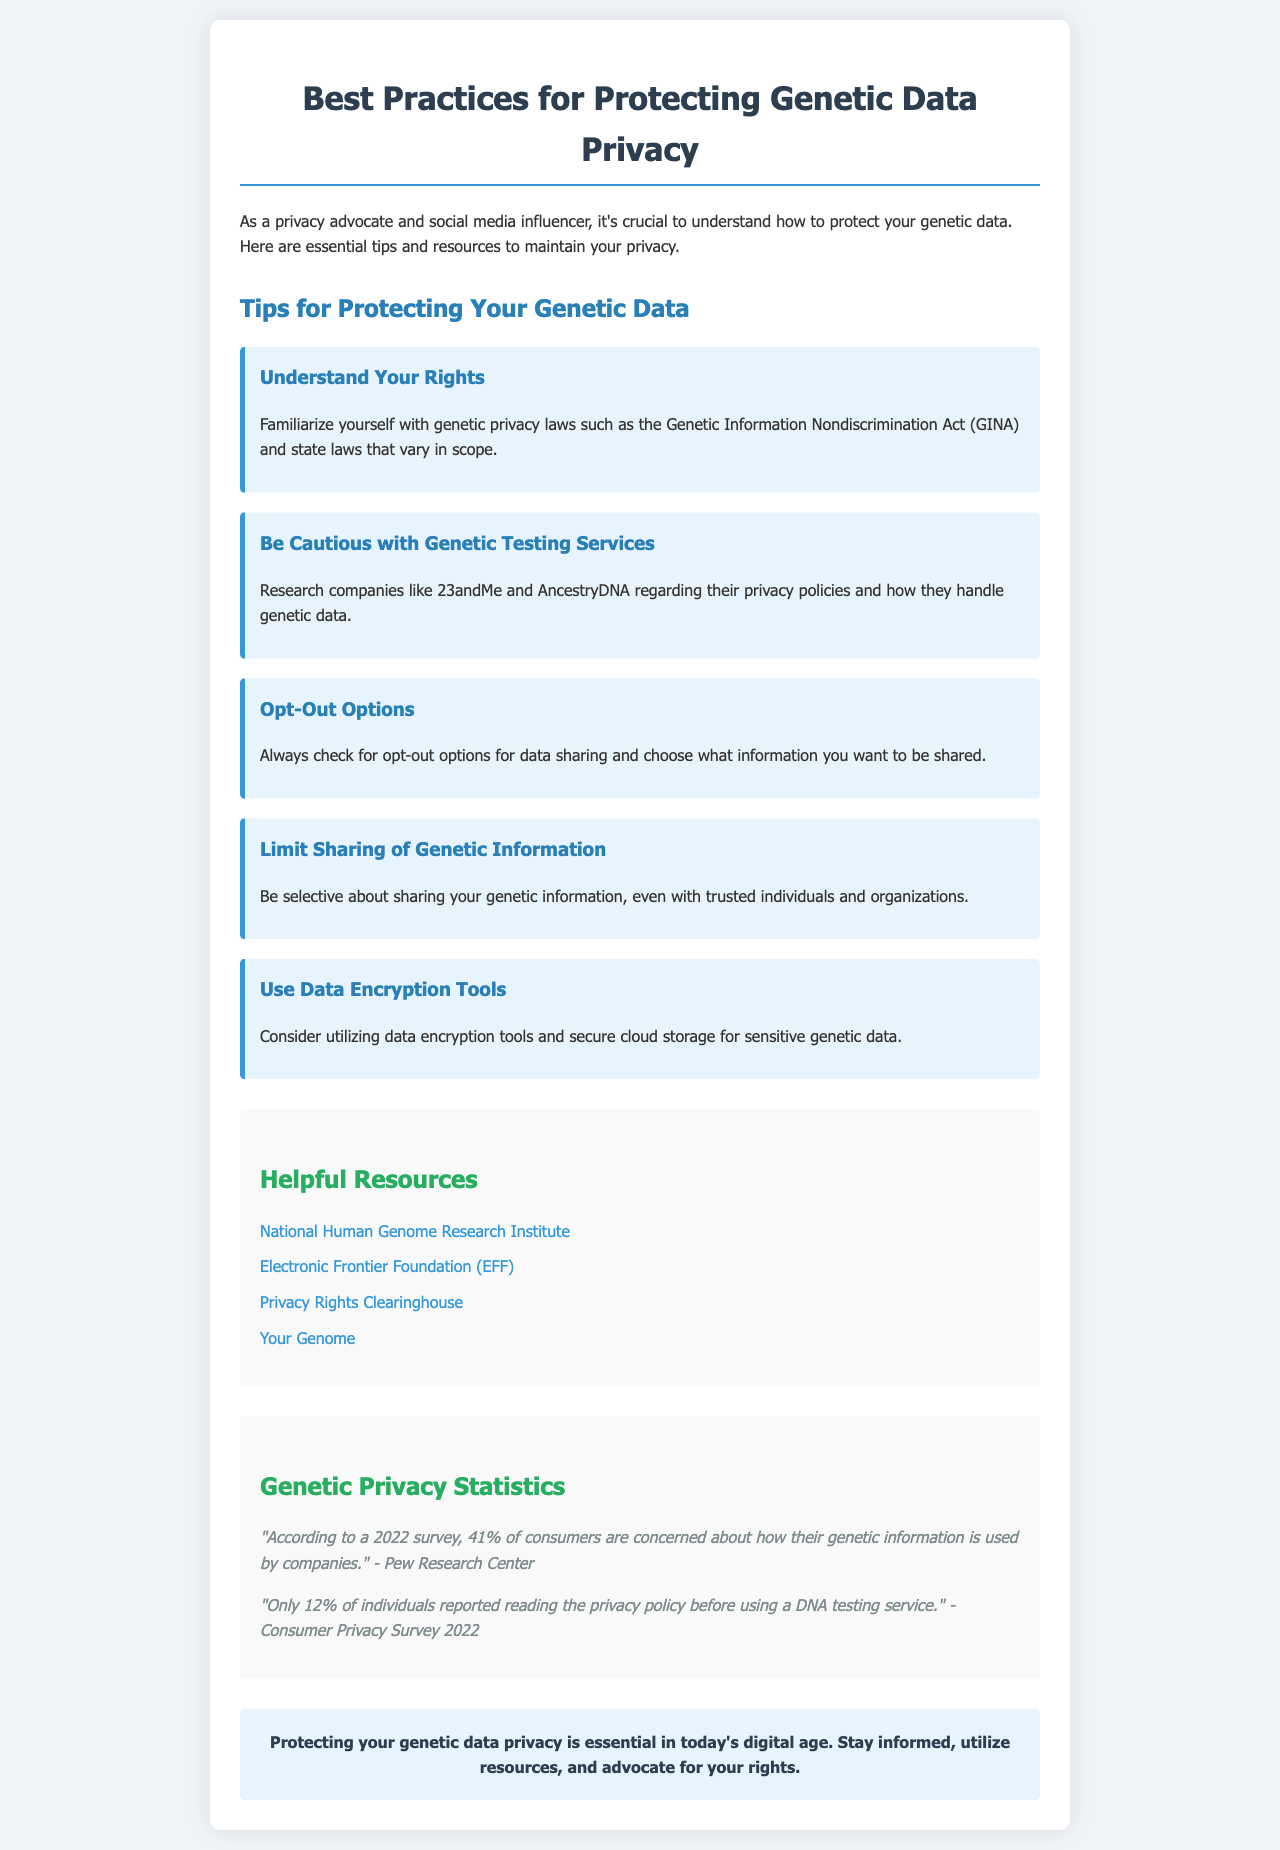What is the title of the document? The title of the document is prominently displayed at the top and is "Best Practices for Protecting Genetic Data Privacy."
Answer: Best Practices for Protecting Genetic Data Privacy What percentage of consumers are concerned about how their genetic information is used? This statistic is found within the "Genetic Privacy Statistics" section, stating that 41% of consumers have this concern.
Answer: 41% What is the primary purpose of the tips listed in the document? The tips are designed to help individuals protect their genetic data privacy, which is stated in the introduction of the document.
Answer: Protect genetic data privacy Which organization provides a resource linked in the document? One of the helpful resources is specifically the National Human Genome Research Institute, mentioned in the "Helpful Resources" section.
Answer: National Human Genome Research Institute How many individuals reported reading the privacy policy before using a DNA testing service? The statistic is found in the "Genetic Privacy Statistics" section, indicating that only 12% of individuals read the privacy policy.
Answer: 12% What should individuals be cautious about according to the tips? The tips suggest being cautious with genetic testing services, which is explicitly stated.
Answer: Genetic testing services What is the background color of the tips section? The document mentions that the tips section has a specific background color, which is light blue (e8f4fd).
Answer: Light blue What should you utilize for sensitive genetic data? The document advises using data encryption tools for better protection of sensitive genetic data.
Answer: Data encryption tools 